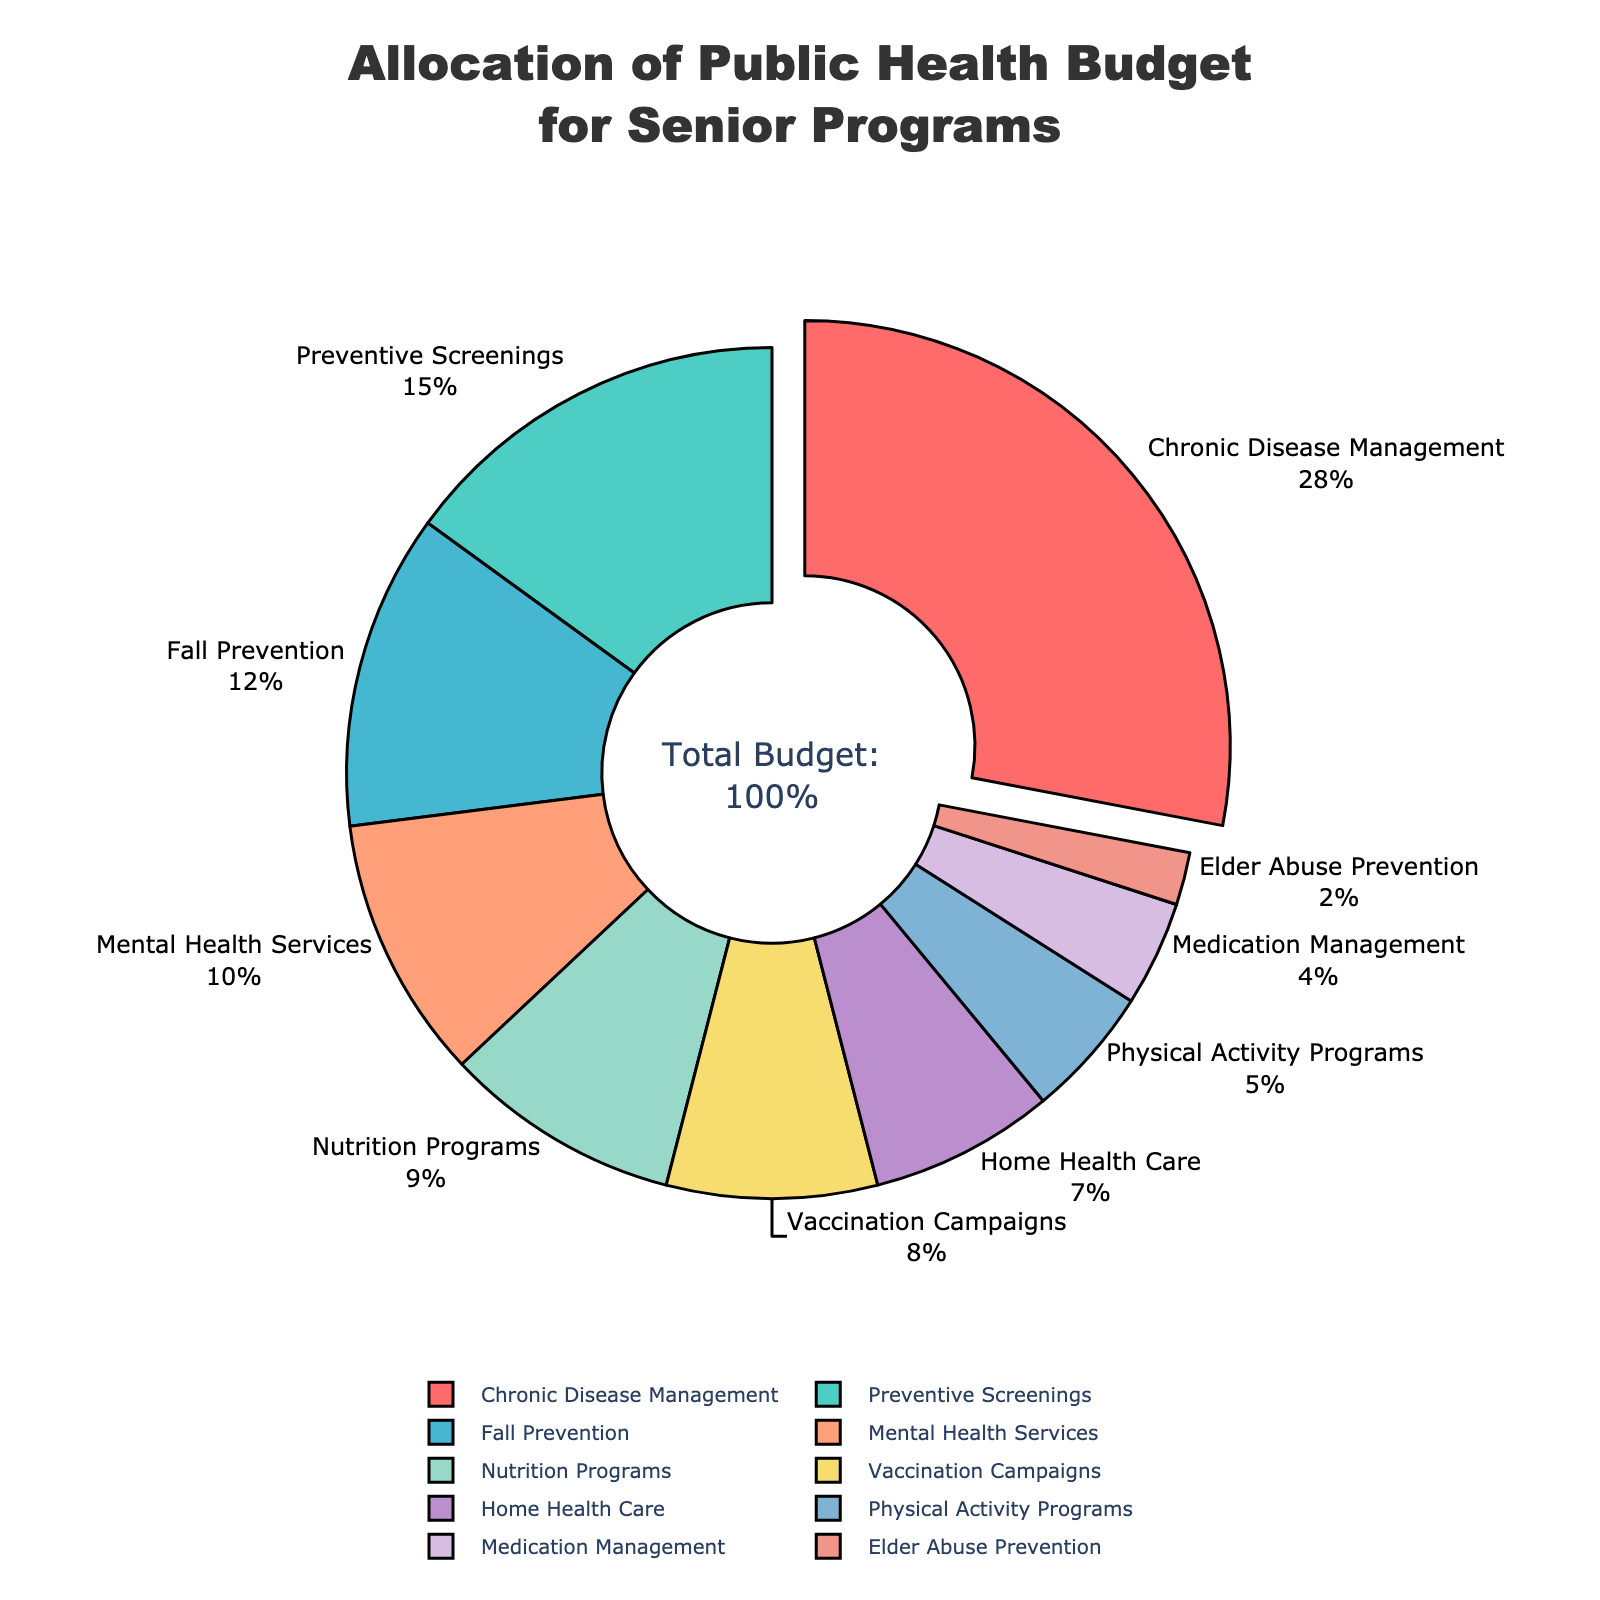What percentage of the budget is allocated to Chronic Disease Management? According to the pie chart, the slice labeled Chronic Disease Management shows a percentage of 28%.
Answer: 28% Which program has the smallest allocation of the public health budget? By observing the smallest slice in the pie chart, the program with the smallest allocation is Elder Abuse Prevention.
Answer: Elder Abuse Prevention How much larger is the budget allocation for Preventive Screenings compared to Nutrition Programs? The allocation for Preventive Screenings is 15%, and for Nutrition Programs, it is 9%. Subtracting 9% from 15% gives the difference.
Answer: 6% What is the total budget allocation percentage for Mental Health Services and Fall Prevention combined? The pie chart shows 10% for Mental Health Services and 12% for Fall Prevention. Adding these together gives the total allocation.
Answer: 22% Which program receives a higher budget allocation: Home Health Care or Physical Activity Programs? Observing the pie chart, Home Health Care has an allocation of 7%, while Physical Activity Programs have 5%. Thus, Home Health Care has a higher allocation.
Answer: Home Health Care What is the total percentage of the budget allocated to Medication Management and Elder Abuse Prevention? The pie chart indicates that Medication Management is allocated 4% and Elder Abuse Prevention 2%. Adding these together gives the total budget.
Answer: 6% How does the budget allocation for Vaccination Campaigns compare to that of Nutrition Programs? By comparing the slices, Vaccination Campaigns have 8%, and Nutrition Programs have 9%. Nutrition Programs receive a marginally higher allocation.
Answer: Nutrition Programs What visual feature highlights the program with the highest budget allocation? The pie chart indicates that the slice representing Chronic Disease Management is slightly pulled out to emphasize its higher allocation.
Answer: Pulled out slice What is the combined budget allocation percentage for all the programs receiving less than 10% each? Summing the percentages of Fall Prevention (12%), Mental Health Services (10%), Nutrition Programs (9%), Vaccination Campaigns (8%), Home Health Care (7%), Physical Activity Programs (5%), Medication Management (4%), and Elder Abuse Prevention (2%) gives the total.
Answer: 57% Is the budget allocation for Home Health Care greater than or equal to that for Mental Health Services? By looking at the pie chart, Home Health Care has a 7% allocation, while Mental Health Services have 10%. Therefore, Home Health Care has a lower allocation.
Answer: No 